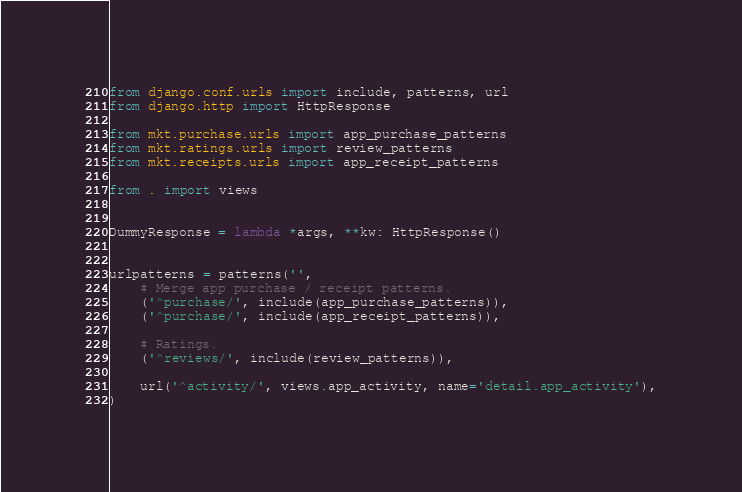Convert code to text. <code><loc_0><loc_0><loc_500><loc_500><_Python_>from django.conf.urls import include, patterns, url
from django.http import HttpResponse

from mkt.purchase.urls import app_purchase_patterns
from mkt.ratings.urls import review_patterns
from mkt.receipts.urls import app_receipt_patterns

from . import views


DummyResponse = lambda *args, **kw: HttpResponse()


urlpatterns = patterns('',
    # Merge app purchase / receipt patterns.
    ('^purchase/', include(app_purchase_patterns)),
    ('^purchase/', include(app_receipt_patterns)),

    # Ratings.
    ('^reviews/', include(review_patterns)),

    url('^activity/', views.app_activity, name='detail.app_activity'),
)
</code> 